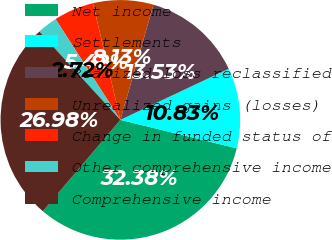Convert chart. <chart><loc_0><loc_0><loc_500><loc_500><pie_chart><fcel>Net income<fcel>Settlements<fcel>Realized loss reclassified<fcel>Unrealized gains (losses)<fcel>Change in funded status of<fcel>Other comprehensive income<fcel>Comprehensive income<nl><fcel>32.38%<fcel>10.83%<fcel>13.53%<fcel>8.13%<fcel>5.42%<fcel>2.72%<fcel>26.98%<nl></chart> 